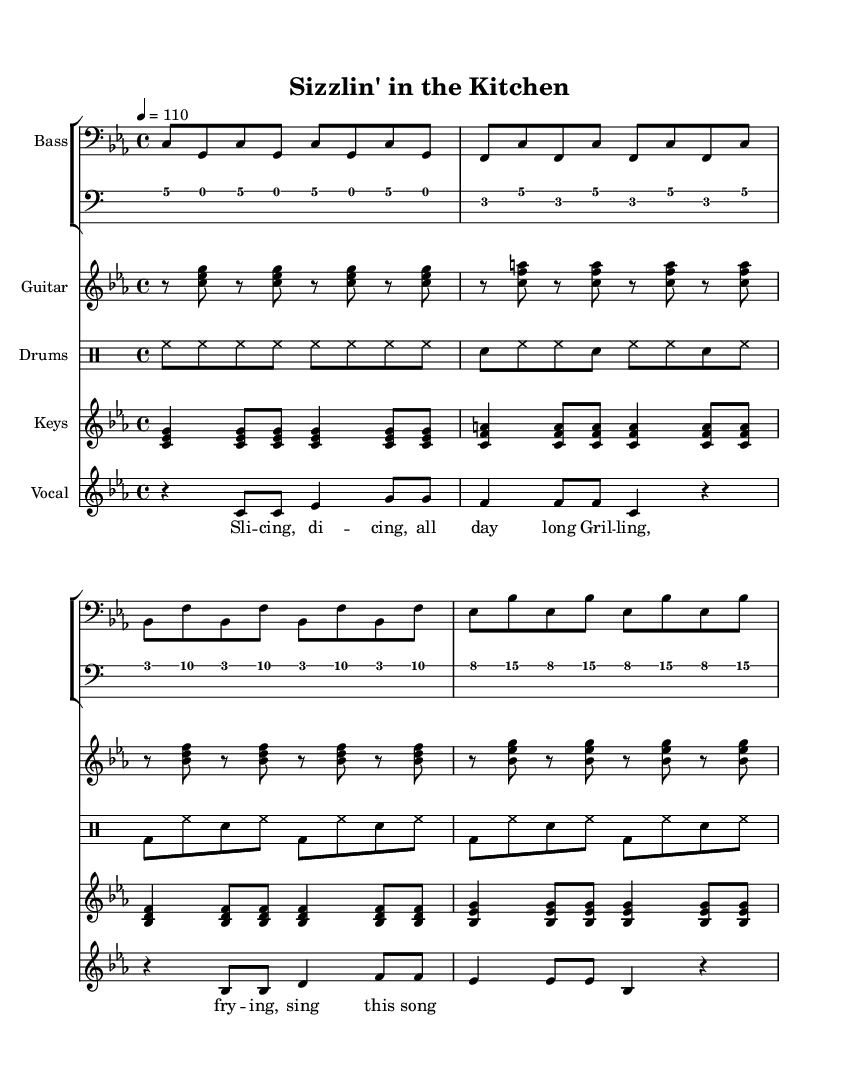What is the key signature of this music? The key signature indicates the key of C minor, which contains three flats (B flat, E flat, and A flat). We determine this by looking at the initial part of the score where the key is indicated.
Answer: C minor What is the time signature of this music? The time signature is 4/4, as indicated at the beginning of the score. This means there are four beats per measure, and each beat is a quarter note.
Answer: 4/4 What is the tempo marking for this piece? The tempo marking indicates a speed of 110 beats per minute, which is typical for Funk music to maintain a lively groove. This is found near the top of the score where the tempo is specified.
Answer: 110 How many measures are in the bass line? The bass line contains four measures of music before it repeats. By counting the measures indicated by the vertical lines in the score, we find four sections.
Answer: 4 What rhythmic element differentiates the drum pattern from others? The drum pattern features a consistent eighth-note hi-hat pattern, which is a staple in Funk music to create a driving groove. The distinct use of hi-hats can be noticed throughout the measure.
Answer: Hi-hat Which instrument plays the main melody in the score? The vocals carry the main melody of the piece, allowing for lyrical storytelling about a cafe chef's daily grind. This is indicated by the vocal staff at the bottom of the score.
Answer: Vocals What type of chords are prevalent in the guitar riff? The guitar riff consists mainly of triads, which are chord shapes that create harmony in Funk music to support the rhythm section. These triads are evident in the notes played simultaneously in the guitar part.
Answer: Triads 